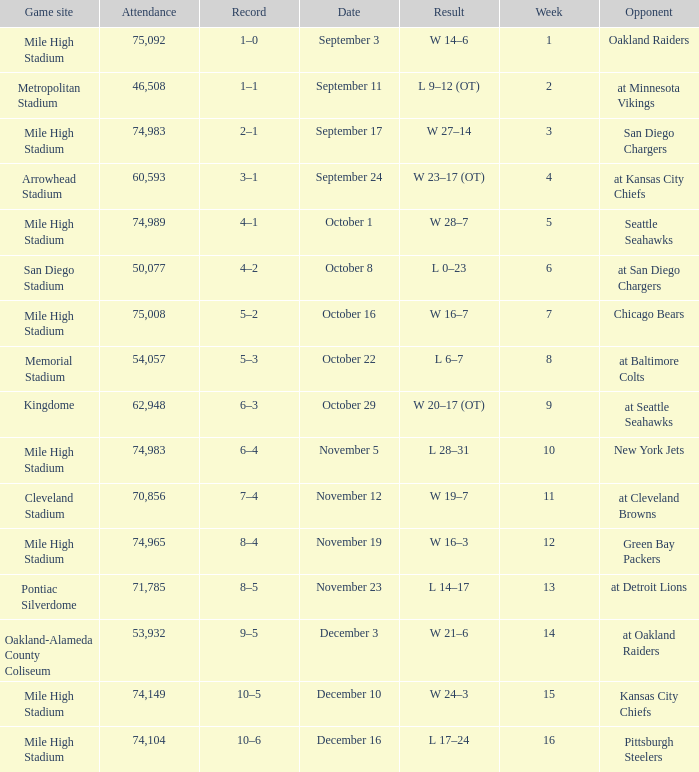On what date was the result w 28–7? October 1. 